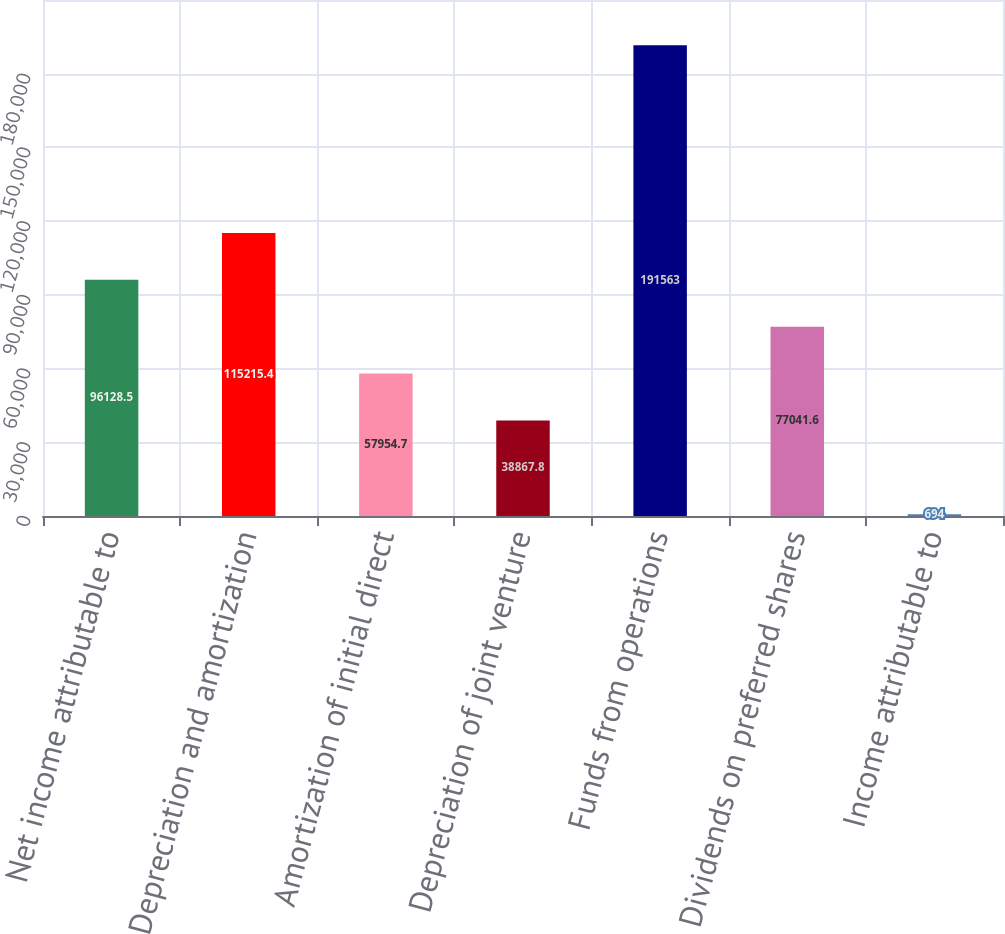Convert chart. <chart><loc_0><loc_0><loc_500><loc_500><bar_chart><fcel>Net income attributable to<fcel>Depreciation and amortization<fcel>Amortization of initial direct<fcel>Depreciation of joint venture<fcel>Funds from operations<fcel>Dividends on preferred shares<fcel>Income attributable to<nl><fcel>96128.5<fcel>115215<fcel>57954.7<fcel>38867.8<fcel>191563<fcel>77041.6<fcel>694<nl></chart> 